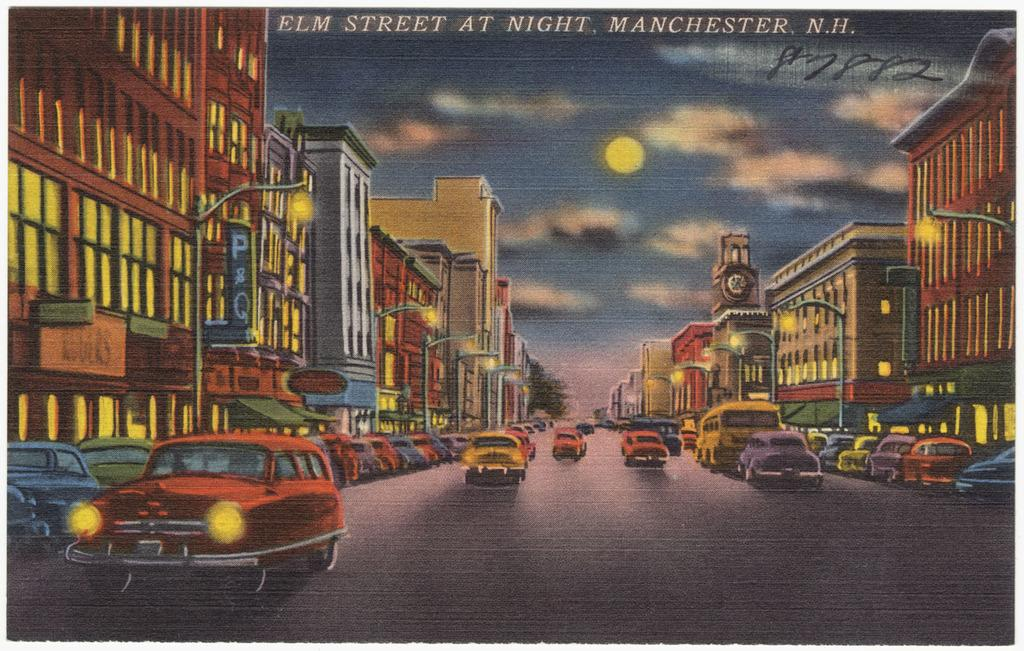<image>
Summarize the visual content of the image. a post card cover of a street reading Elm Street at Night 